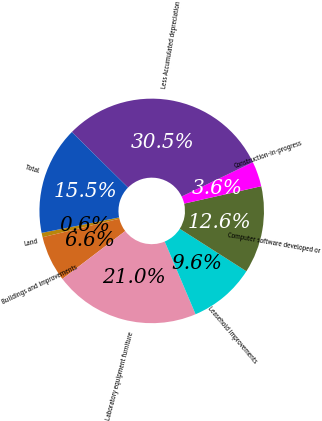<chart> <loc_0><loc_0><loc_500><loc_500><pie_chart><fcel>Land<fcel>Buildings and improvements<fcel>Laboratory equipment furniture<fcel>Leasehold improvements<fcel>Computer software developed or<fcel>Construction-in-progress<fcel>Less Accumulated depreciation<fcel>Total<nl><fcel>0.63%<fcel>6.59%<fcel>21.03%<fcel>9.58%<fcel>12.56%<fcel>3.61%<fcel>30.46%<fcel>15.54%<nl></chart> 